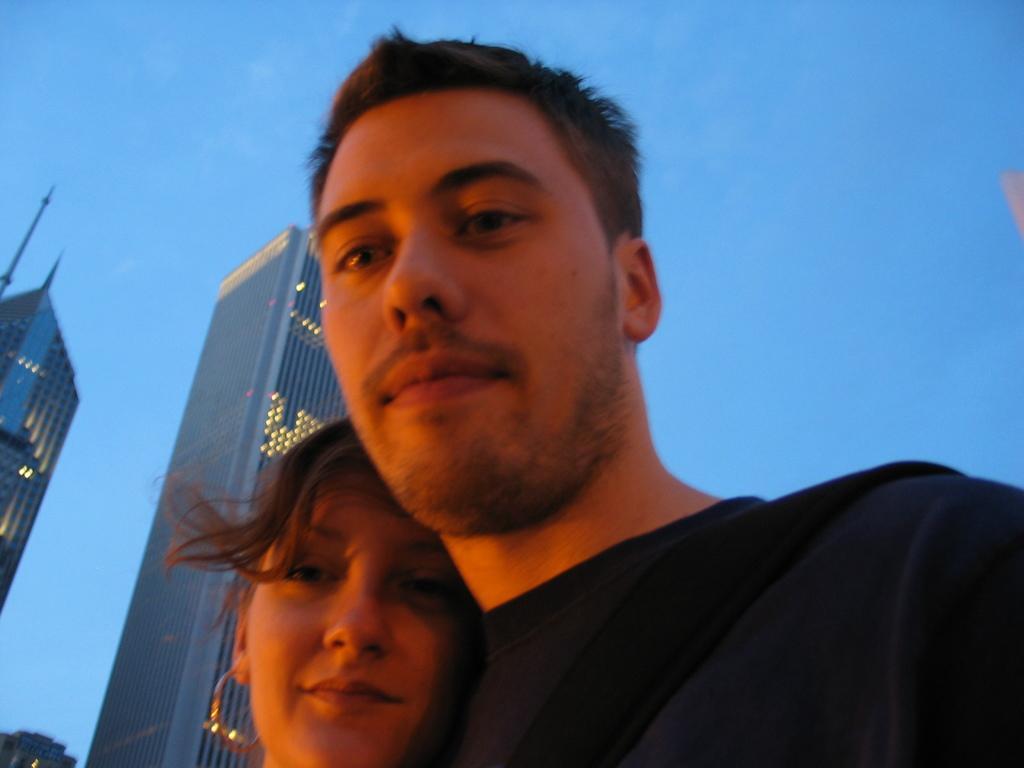Describe this image in one or two sentences. In this picture we can see a man and a woman smiling and at the back of them we can see buildings, lights and in the background we can see the sky. 